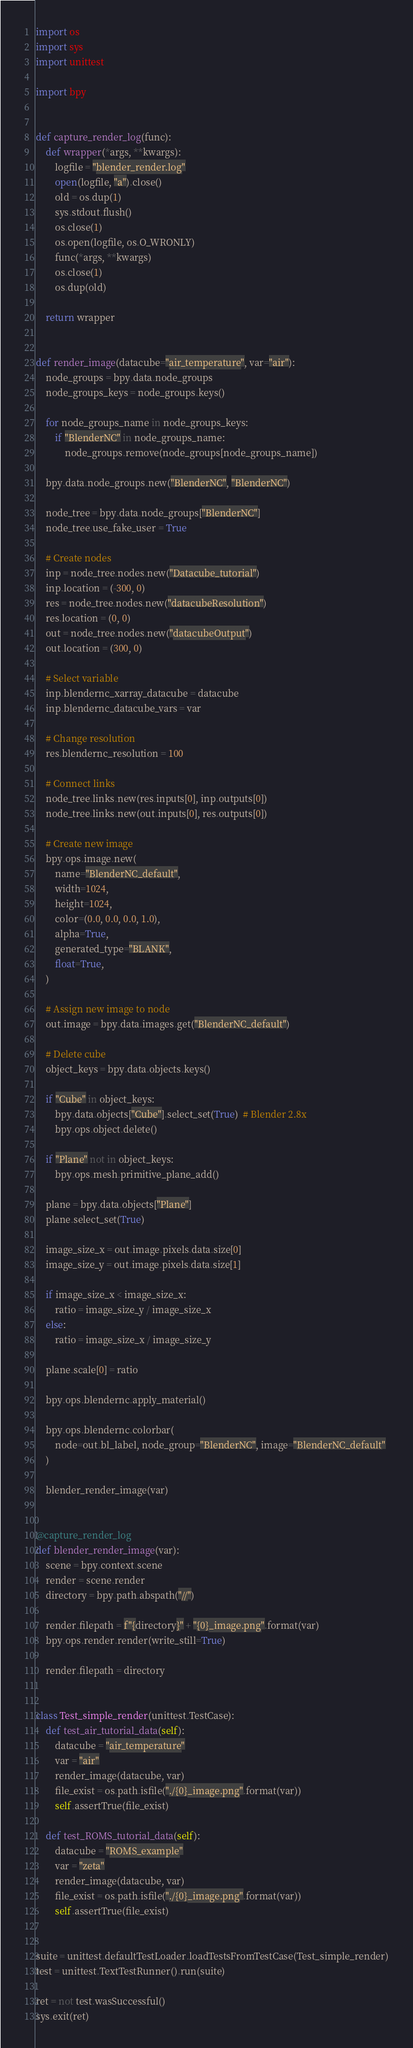Convert code to text. <code><loc_0><loc_0><loc_500><loc_500><_Python_>import os
import sys
import unittest

import bpy


def capture_render_log(func):
    def wrapper(*args, **kwargs):
        logfile = "blender_render.log"
        open(logfile, "a").close()
        old = os.dup(1)
        sys.stdout.flush()
        os.close(1)
        os.open(logfile, os.O_WRONLY)
        func(*args, **kwargs)
        os.close(1)
        os.dup(old)

    return wrapper


def render_image(datacube="air_temperature", var="air"):
    node_groups = bpy.data.node_groups
    node_groups_keys = node_groups.keys()

    for node_groups_name in node_groups_keys:
        if "BlenderNC" in node_groups_name:
            node_groups.remove(node_groups[node_groups_name])

    bpy.data.node_groups.new("BlenderNC", "BlenderNC")

    node_tree = bpy.data.node_groups["BlenderNC"]
    node_tree.use_fake_user = True

    # Create nodes
    inp = node_tree.nodes.new("Datacube_tutorial")
    inp.location = (-300, 0)
    res = node_tree.nodes.new("datacubeResolution")
    res.location = (0, 0)
    out = node_tree.nodes.new("datacubeOutput")
    out.location = (300, 0)

    # Select variable
    inp.blendernc_xarray_datacube = datacube
    inp.blendernc_datacube_vars = var

    # Change resolution
    res.blendernc_resolution = 100

    # Connect links
    node_tree.links.new(res.inputs[0], inp.outputs[0])
    node_tree.links.new(out.inputs[0], res.outputs[0])

    # Create new image
    bpy.ops.image.new(
        name="BlenderNC_default",
        width=1024,
        height=1024,
        color=(0.0, 0.0, 0.0, 1.0),
        alpha=True,
        generated_type="BLANK",
        float=True,
    )

    # Assign new image to node
    out.image = bpy.data.images.get("BlenderNC_default")

    # Delete cube
    object_keys = bpy.data.objects.keys()

    if "Cube" in object_keys:
        bpy.data.objects["Cube"].select_set(True)  # Blender 2.8x
        bpy.ops.object.delete()

    if "Plane" not in object_keys:
        bpy.ops.mesh.primitive_plane_add()

    plane = bpy.data.objects["Plane"]
    plane.select_set(True)

    image_size_x = out.image.pixels.data.size[0]
    image_size_y = out.image.pixels.data.size[1]

    if image_size_x < image_size_x:
        ratio = image_size_y / image_size_x
    else:
        ratio = image_size_x / image_size_y

    plane.scale[0] = ratio

    bpy.ops.blendernc.apply_material()

    bpy.ops.blendernc.colorbar(
        node=out.bl_label, node_group="BlenderNC", image="BlenderNC_default"
    )

    blender_render_image(var)


@capture_render_log
def blender_render_image(var):
    scene = bpy.context.scene
    render = scene.render
    directory = bpy.path.abspath("//")

    render.filepath = f"{directory}" + "{0}_image.png".format(var)
    bpy.ops.render.render(write_still=True)

    render.filepath = directory


class Test_simple_render(unittest.TestCase):
    def test_air_tutorial_data(self):
        datacube = "air_temperature"
        var = "air"
        render_image(datacube, var)
        file_exist = os.path.isfile("./{0}_image.png".format(var))
        self.assertTrue(file_exist)

    def test_ROMS_tutorial_data(self):
        datacube = "ROMS_example"
        var = "zeta"
        render_image(datacube, var)
        file_exist = os.path.isfile("./{0}_image.png".format(var))
        self.assertTrue(file_exist)


suite = unittest.defaultTestLoader.loadTestsFromTestCase(Test_simple_render)
test = unittest.TextTestRunner().run(suite)

ret = not test.wasSuccessful()
sys.exit(ret)
</code> 